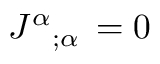Convert formula to latex. <formula><loc_0><loc_0><loc_500><loc_500>J ^ { \alpha _ { ; \alpha } \, = 0</formula> 